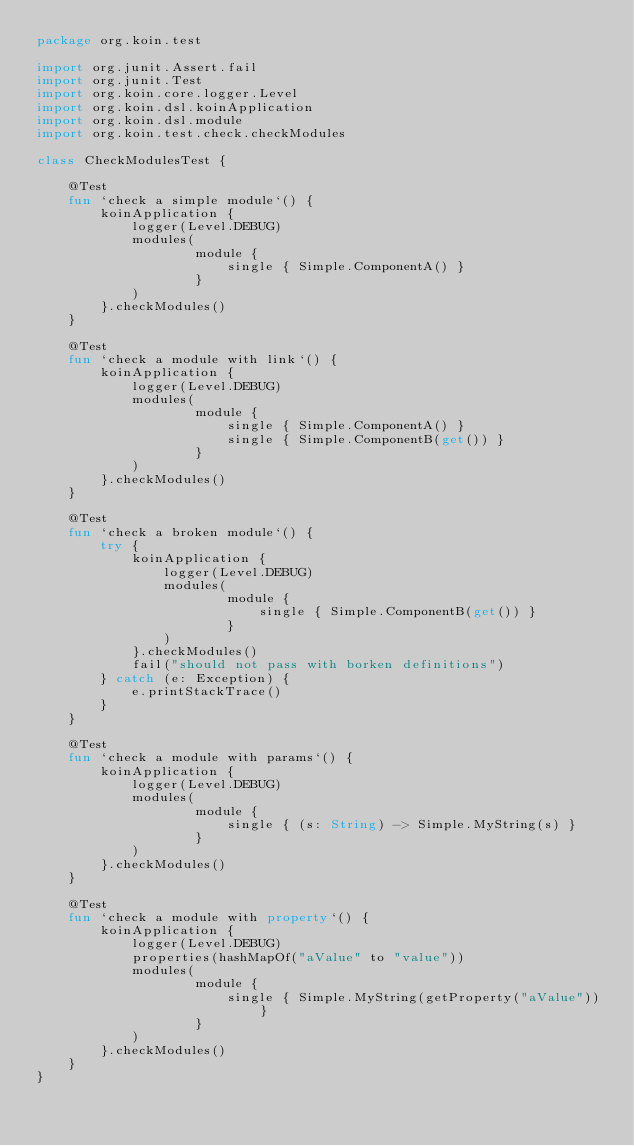Convert code to text. <code><loc_0><loc_0><loc_500><loc_500><_Kotlin_>package org.koin.test

import org.junit.Assert.fail
import org.junit.Test
import org.koin.core.logger.Level
import org.koin.dsl.koinApplication
import org.koin.dsl.module
import org.koin.test.check.checkModules

class CheckModulesTest {

    @Test
    fun `check a simple module`() {
        koinApplication {
            logger(Level.DEBUG)
            modules(
                    module {
                        single { Simple.ComponentA() }
                    }
            )
        }.checkModules()
    }

    @Test
    fun `check a module with link`() {
        koinApplication {
            logger(Level.DEBUG)
            modules(
                    module {
                        single { Simple.ComponentA() }
                        single { Simple.ComponentB(get()) }
                    }
            )
        }.checkModules()
    }

    @Test
    fun `check a broken module`() {
        try {
            koinApplication {
                logger(Level.DEBUG)
                modules(
                        module {
                            single { Simple.ComponentB(get()) }
                        }
                )
            }.checkModules()
            fail("should not pass with borken definitions")
        } catch (e: Exception) {
            e.printStackTrace()
        }
    }

    @Test
    fun `check a module with params`() {
        koinApplication {
            logger(Level.DEBUG)
            modules(
                    module {
                        single { (s: String) -> Simple.MyString(s) }
                    }
            )
        }.checkModules()
    }

    @Test
    fun `check a module with property`() {
        koinApplication {
            logger(Level.DEBUG)
            properties(hashMapOf("aValue" to "value"))
            modules(
                    module {
                        single { Simple.MyString(getProperty("aValue")) }
                    }
            )
        }.checkModules()
    }
}</code> 